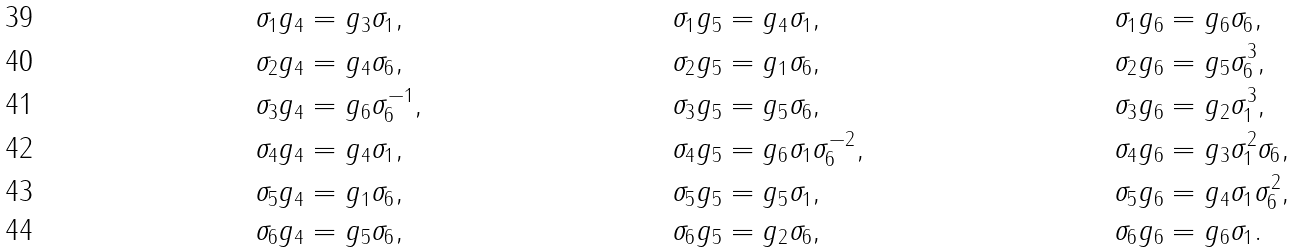<formula> <loc_0><loc_0><loc_500><loc_500>\sigma _ { 1 } g _ { 4 } & = g _ { 3 } \sigma _ { 1 } , & \sigma _ { 1 } g _ { 5 } & = g _ { 4 } \sigma _ { 1 } , & \sigma _ { 1 } g _ { 6 } & = g _ { 6 } \sigma _ { 6 } , \\ \sigma _ { 2 } g _ { 4 } & = g _ { 4 } \sigma _ { 6 } , & \sigma _ { 2 } g _ { 5 } & = g _ { 1 } \sigma _ { 6 } , & \sigma _ { 2 } g _ { 6 } & = g _ { 5 } \sigma _ { 6 } ^ { 3 } , \\ \sigma _ { 3 } g _ { 4 } & = g _ { 6 } \sigma _ { 6 } ^ { - 1 } , & \sigma _ { 3 } g _ { 5 } & = g _ { 5 } \sigma _ { 6 } , & \sigma _ { 3 } g _ { 6 } & = g _ { 2 } \sigma _ { 1 } ^ { 3 } , \\ \sigma _ { 4 } g _ { 4 } & = g _ { 4 } \sigma _ { 1 } , & \sigma _ { 4 } g _ { 5 } & = g _ { 6 } \sigma _ { 1 } \sigma _ { 6 } ^ { - 2 } , & \sigma _ { 4 } g _ { 6 } & = g _ { 3 } \sigma _ { 1 } ^ { 2 } \sigma _ { 6 } , \\ \sigma _ { 5 } g _ { 4 } & = g _ { 1 } \sigma _ { 6 } , & \sigma _ { 5 } g _ { 5 } & = g _ { 5 } \sigma _ { 1 } , & \sigma _ { 5 } g _ { 6 } & = g _ { 4 } \sigma _ { 1 } \sigma _ { 6 } ^ { 2 } , \\ \sigma _ { 6 } g _ { 4 } & = g _ { 5 } \sigma _ { 6 } , & \sigma _ { 6 } g _ { 5 } & = g _ { 2 } \sigma _ { 6 } , & \sigma _ { 6 } g _ { 6 } & = g _ { 6 } \sigma _ { 1 } .</formula> 